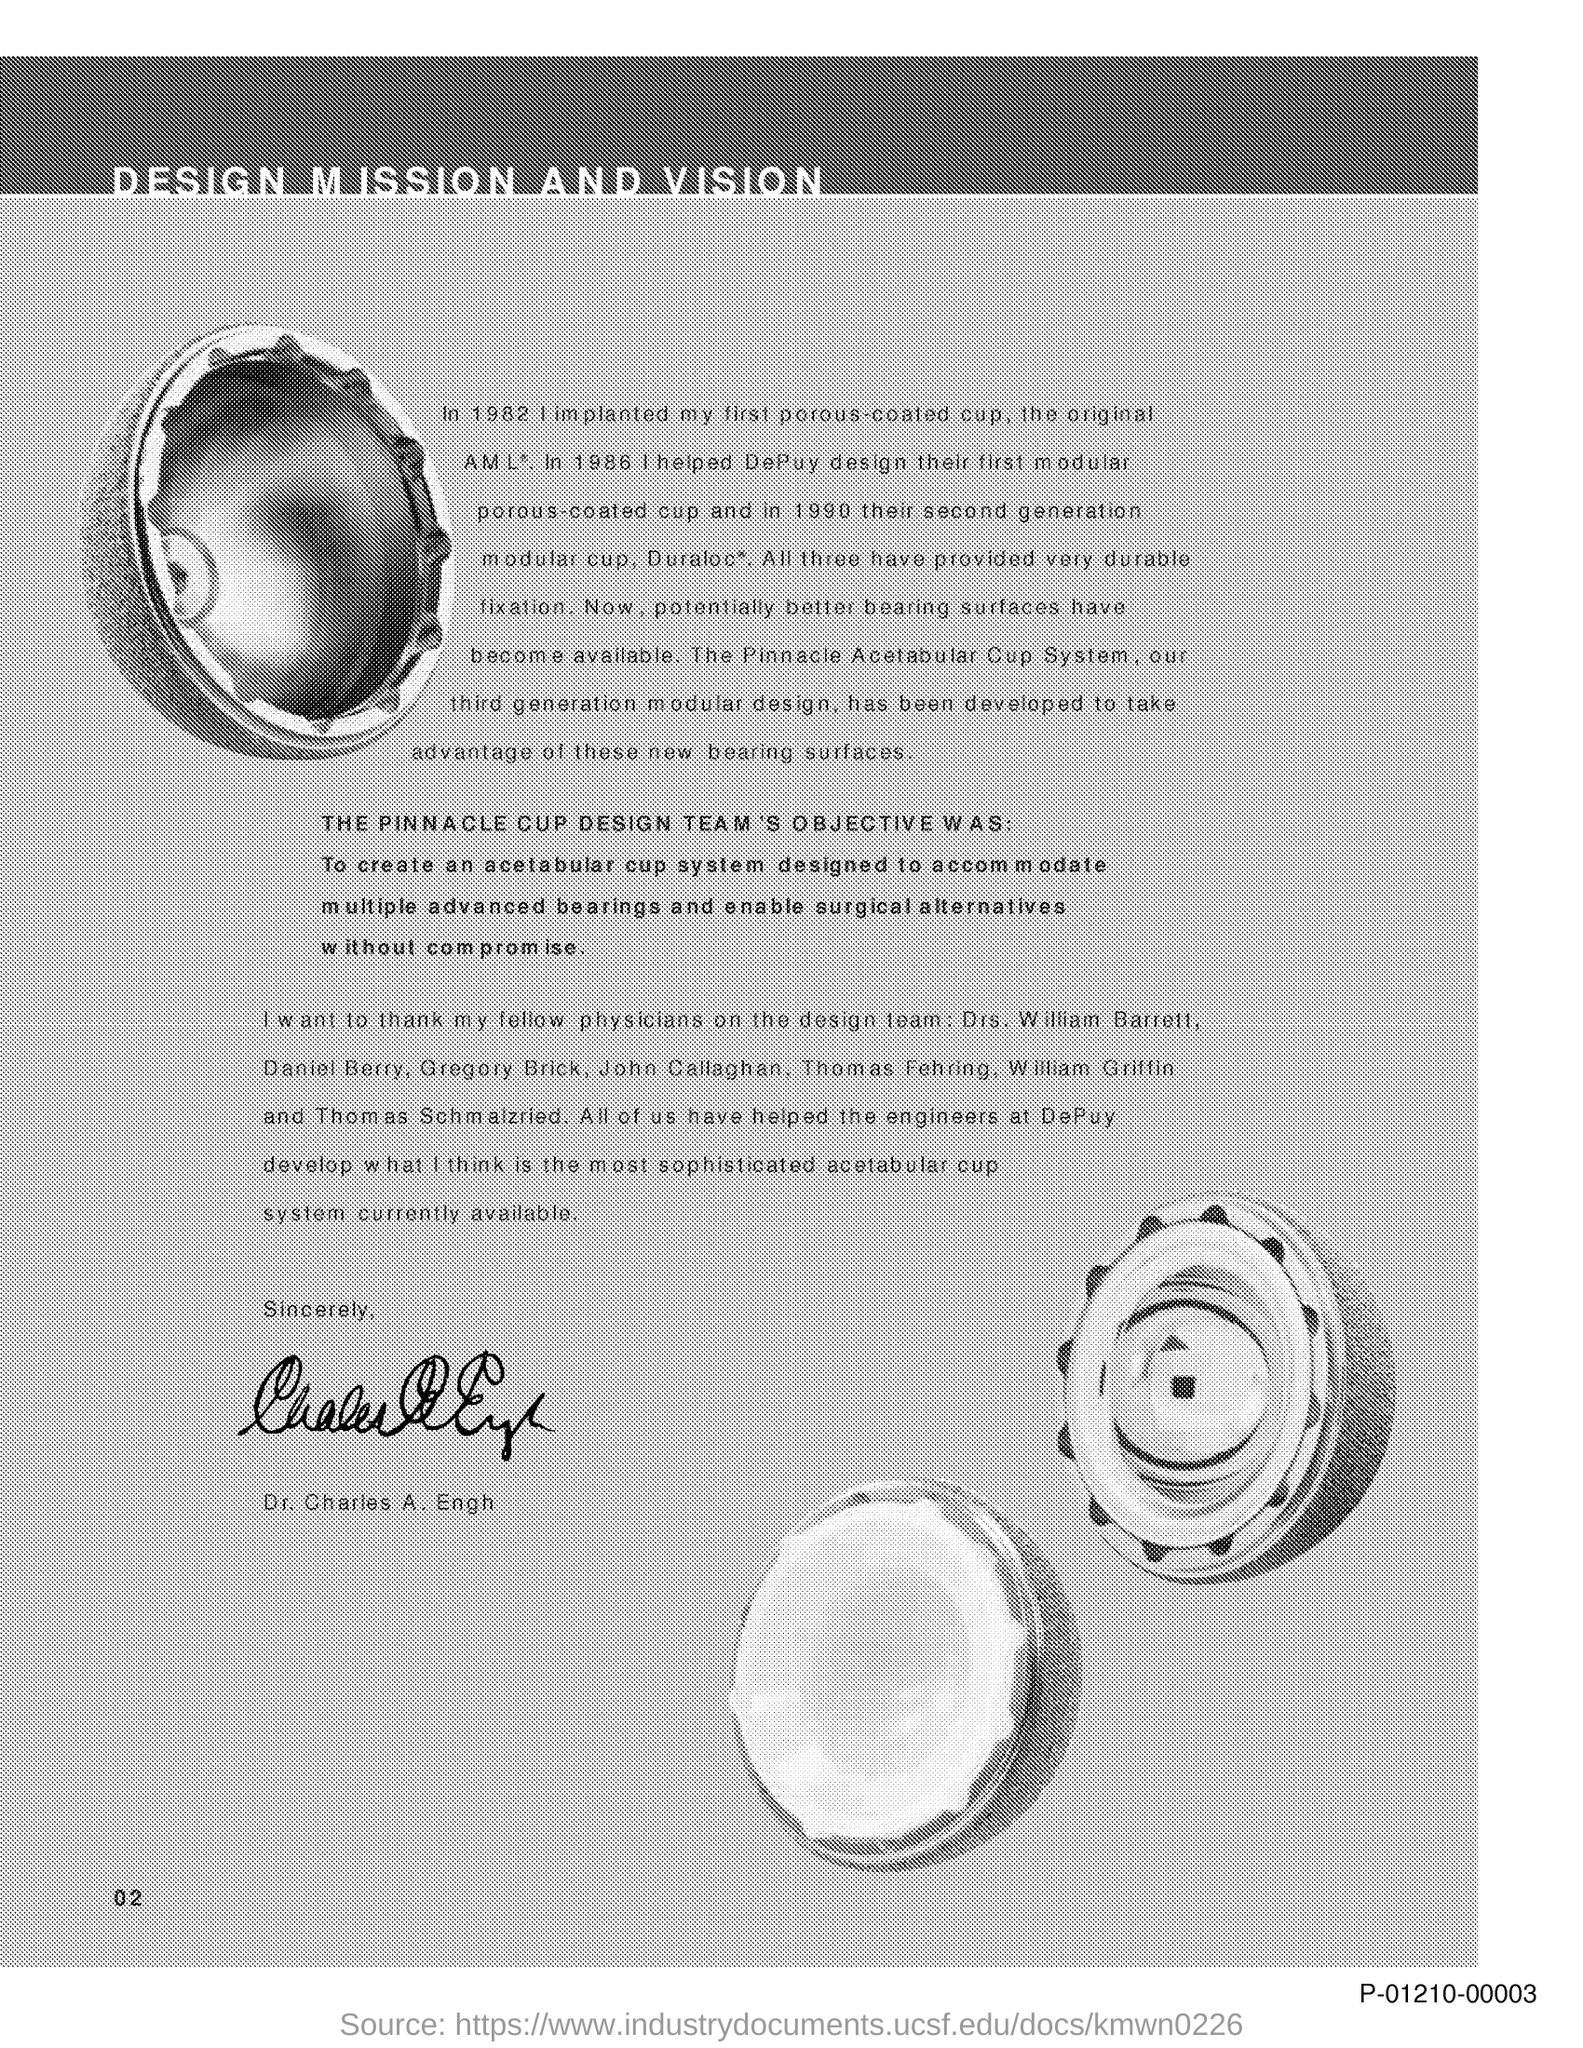What is the title of the document?
Ensure brevity in your answer.  Design Mission and Vision. 